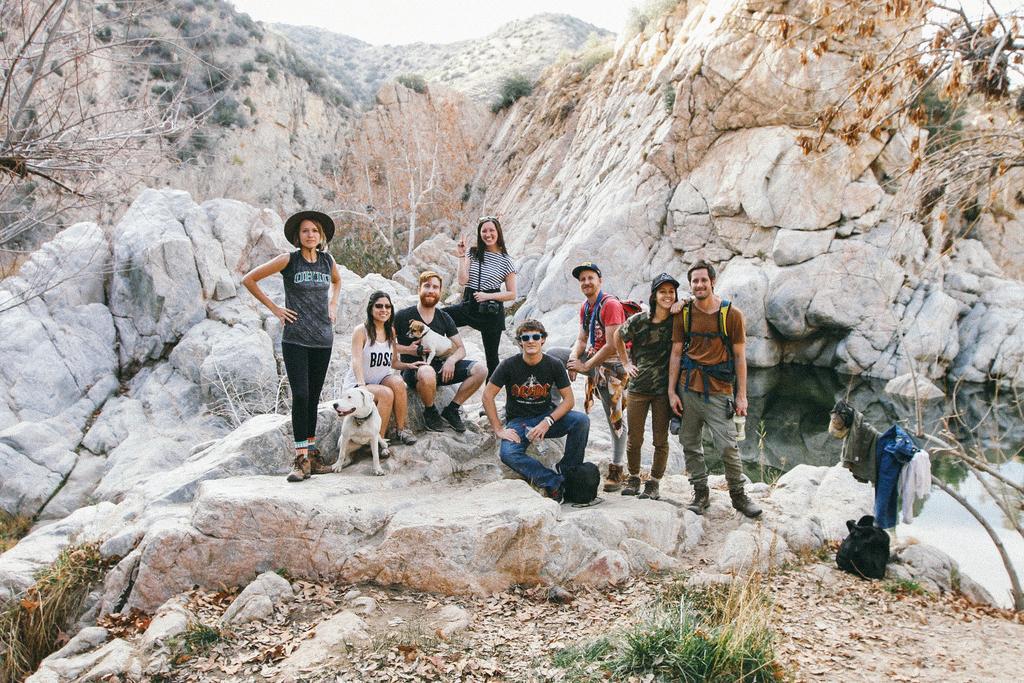Please provide a concise description of this image. In the middle of the image a group of people is smiling. Behind them there is a tree. Behind the tree there is a hill. At the top of the image there is sky. Bottom middle of the image there is grass. Bottom right side of the image there are some clothes. In the middle of the image a man is holding a dog. 